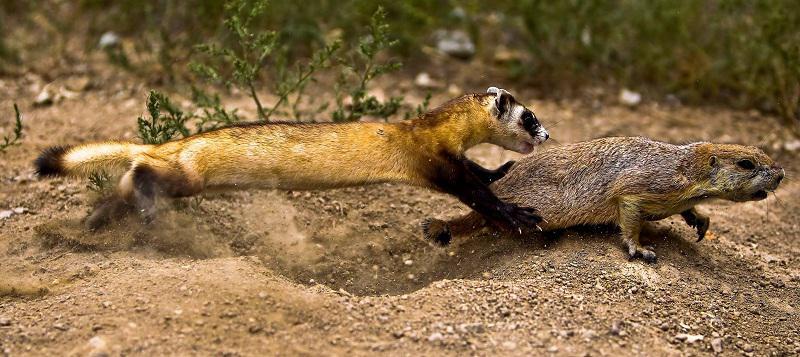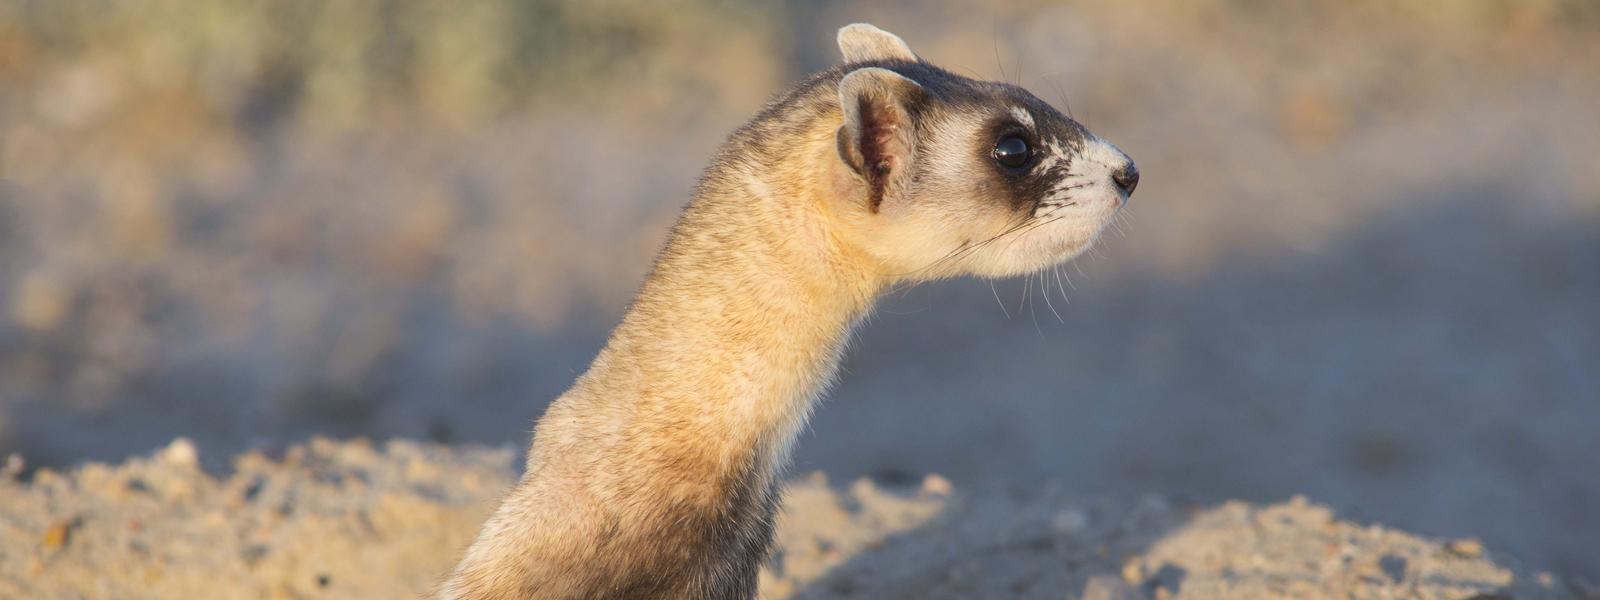The first image is the image on the left, the second image is the image on the right. Analyze the images presented: Is the assertion "An animal in one image is caught leaping in mid-air." valid? Answer yes or no. Yes. The first image is the image on the left, the second image is the image on the right. Considering the images on both sides, is "In both images, the ferret's head is stretched up to gaze about." valid? Answer yes or no. No. 